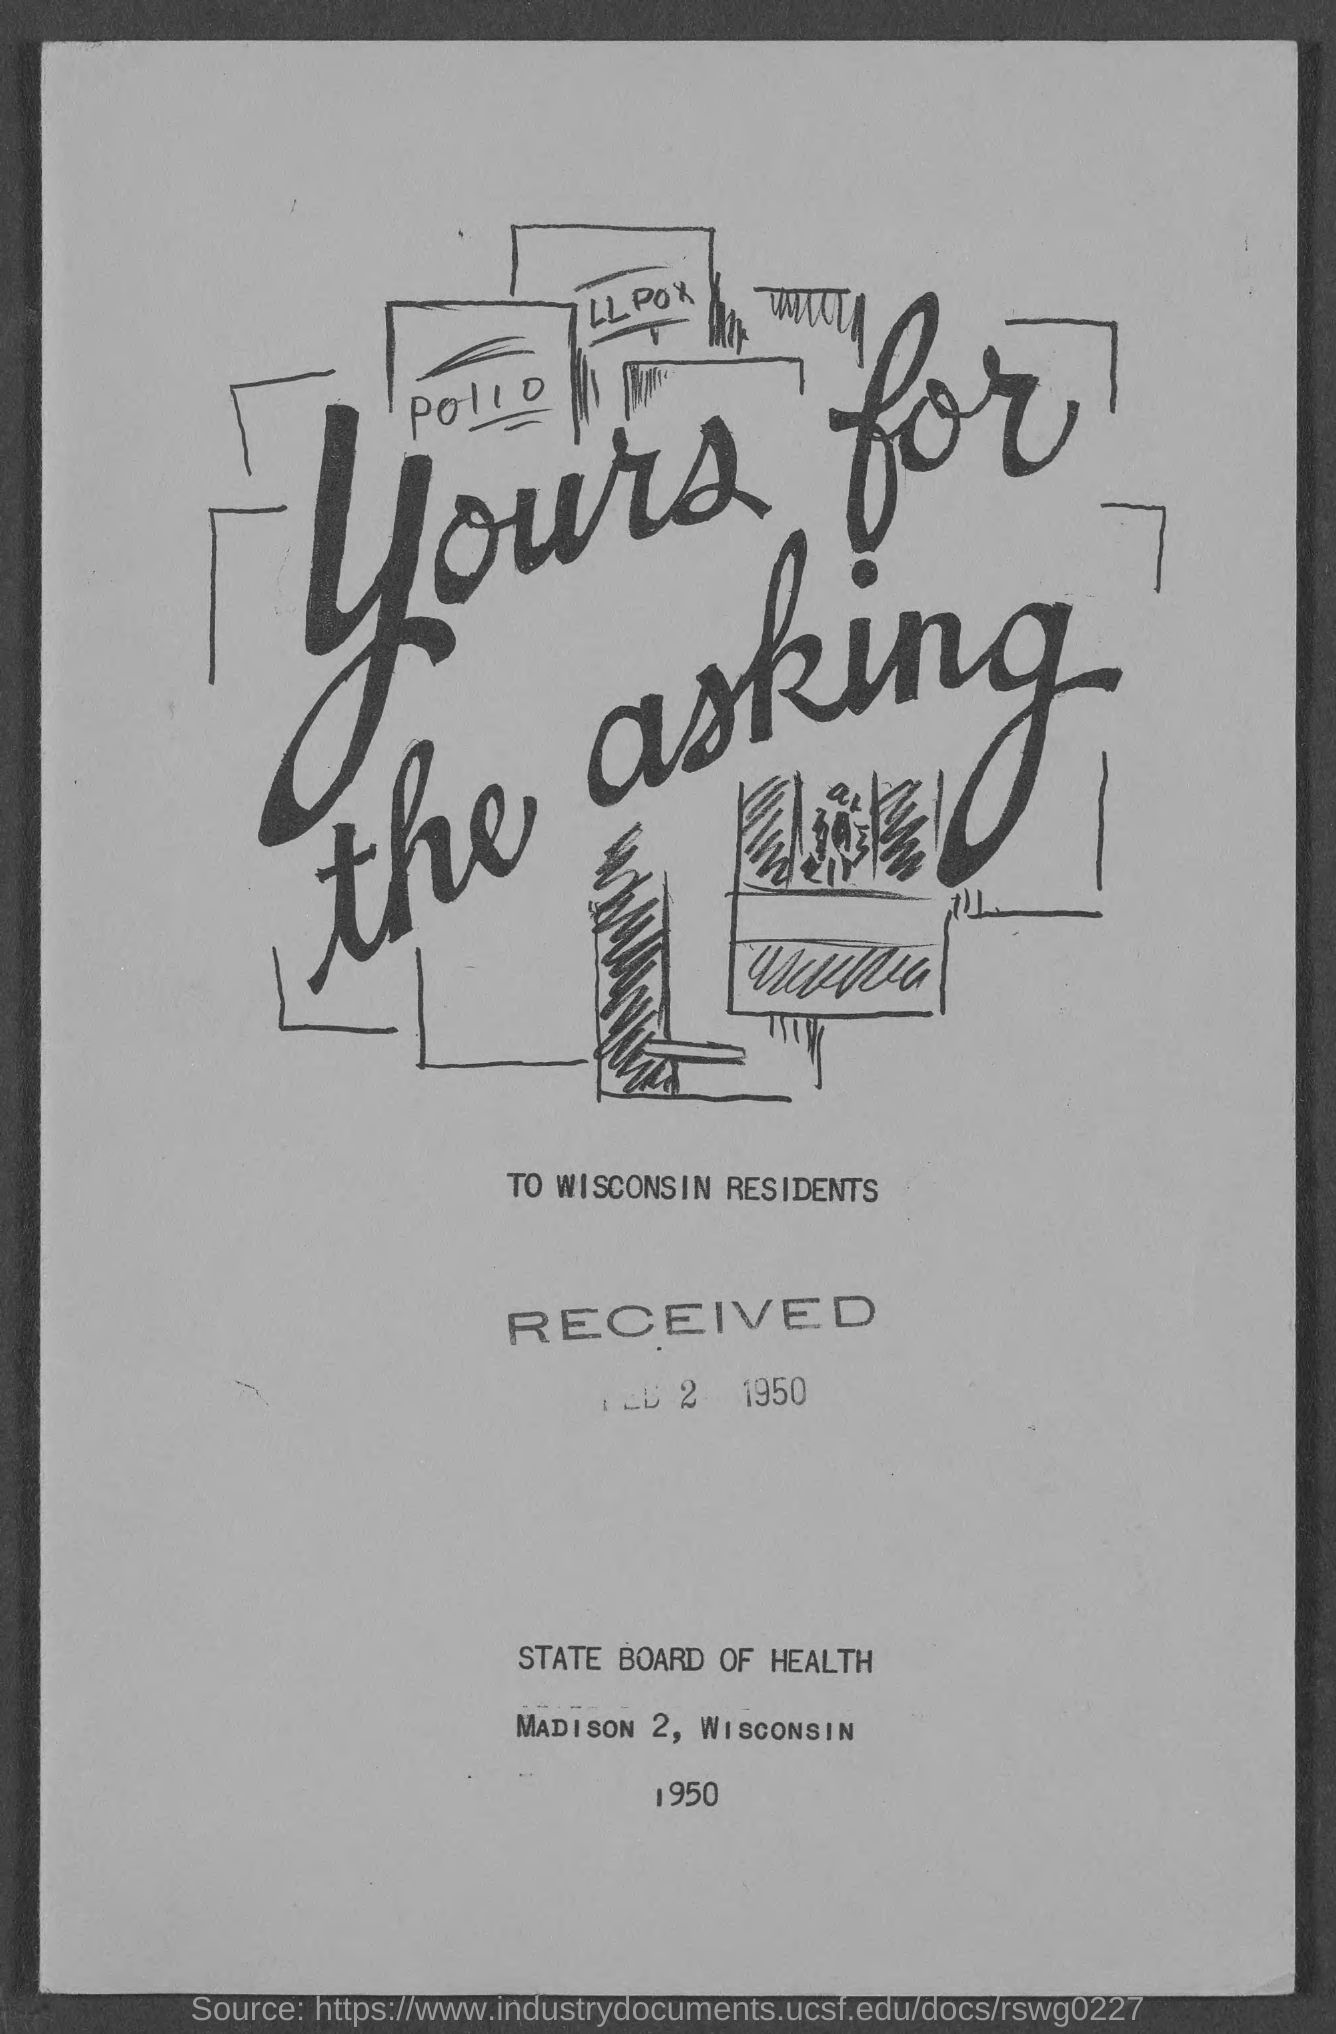Point out several critical features in this image. The year mentioned at the bottom of the document is 1950. This document is released by the State Board of Health. The document was received on February 2, 1950. The document specifically mentions Wisconsin residents. 